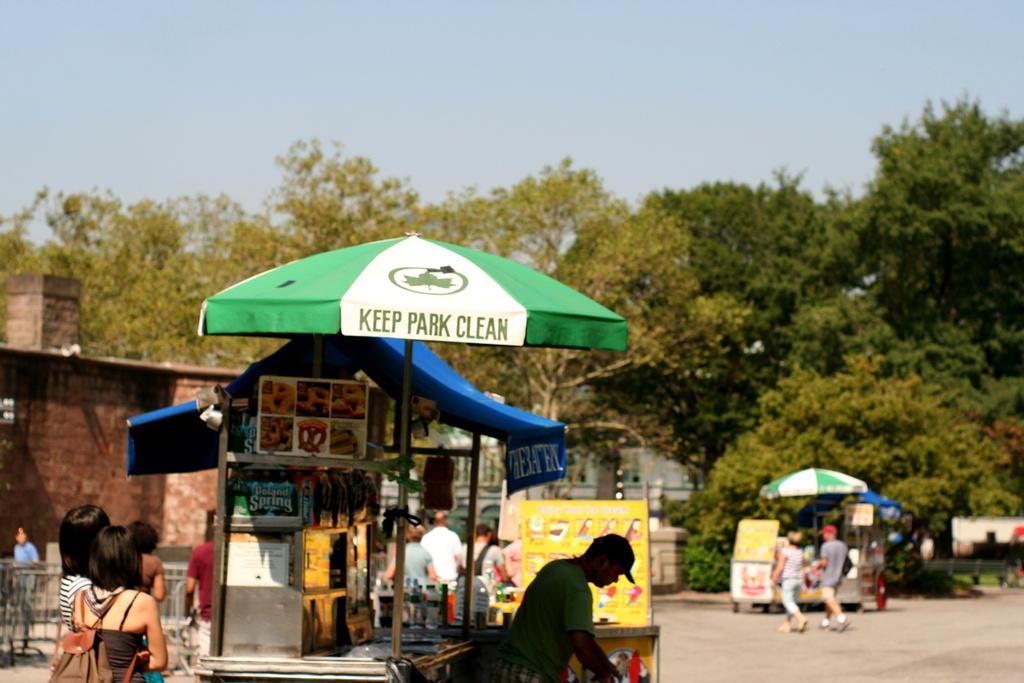Can you describe this image briefly? This Picture consists of road , on the road I can see tents and a shop under the tent shop and a person visible in front of the tent and a bottle visible backside of person kept on table and I can see there are few persons walking on the road and I can see another tent visible on the right side and trees and in the middle I can see the sky , on the left I can see building , person 